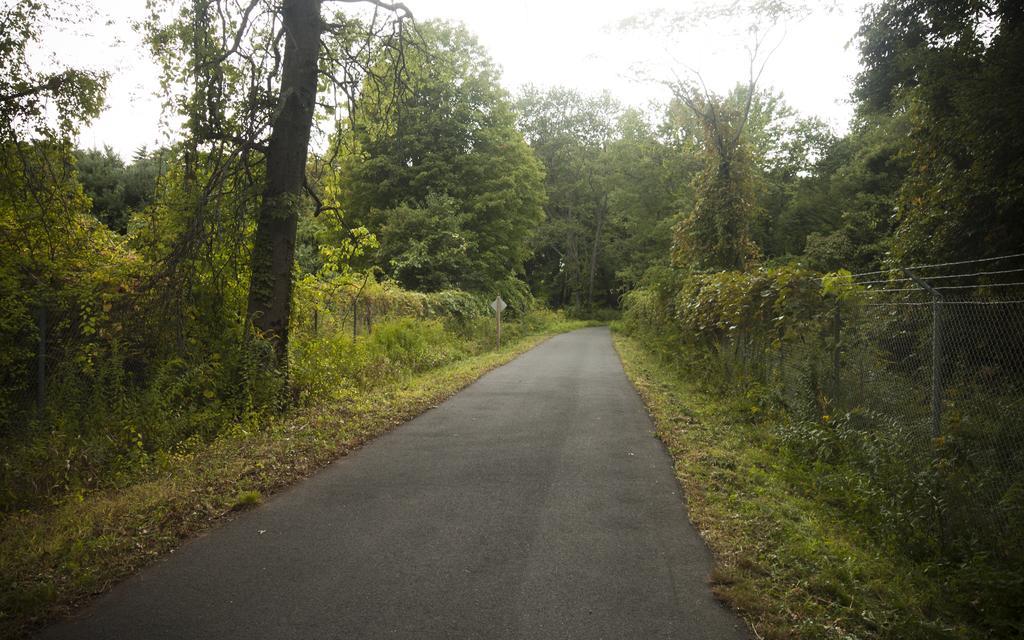Describe this image in one or two sentences. In this image, there is an outside view. There is a road in between trees. There is a fencing on the right side of the image. There is a sky at the top of the image. 